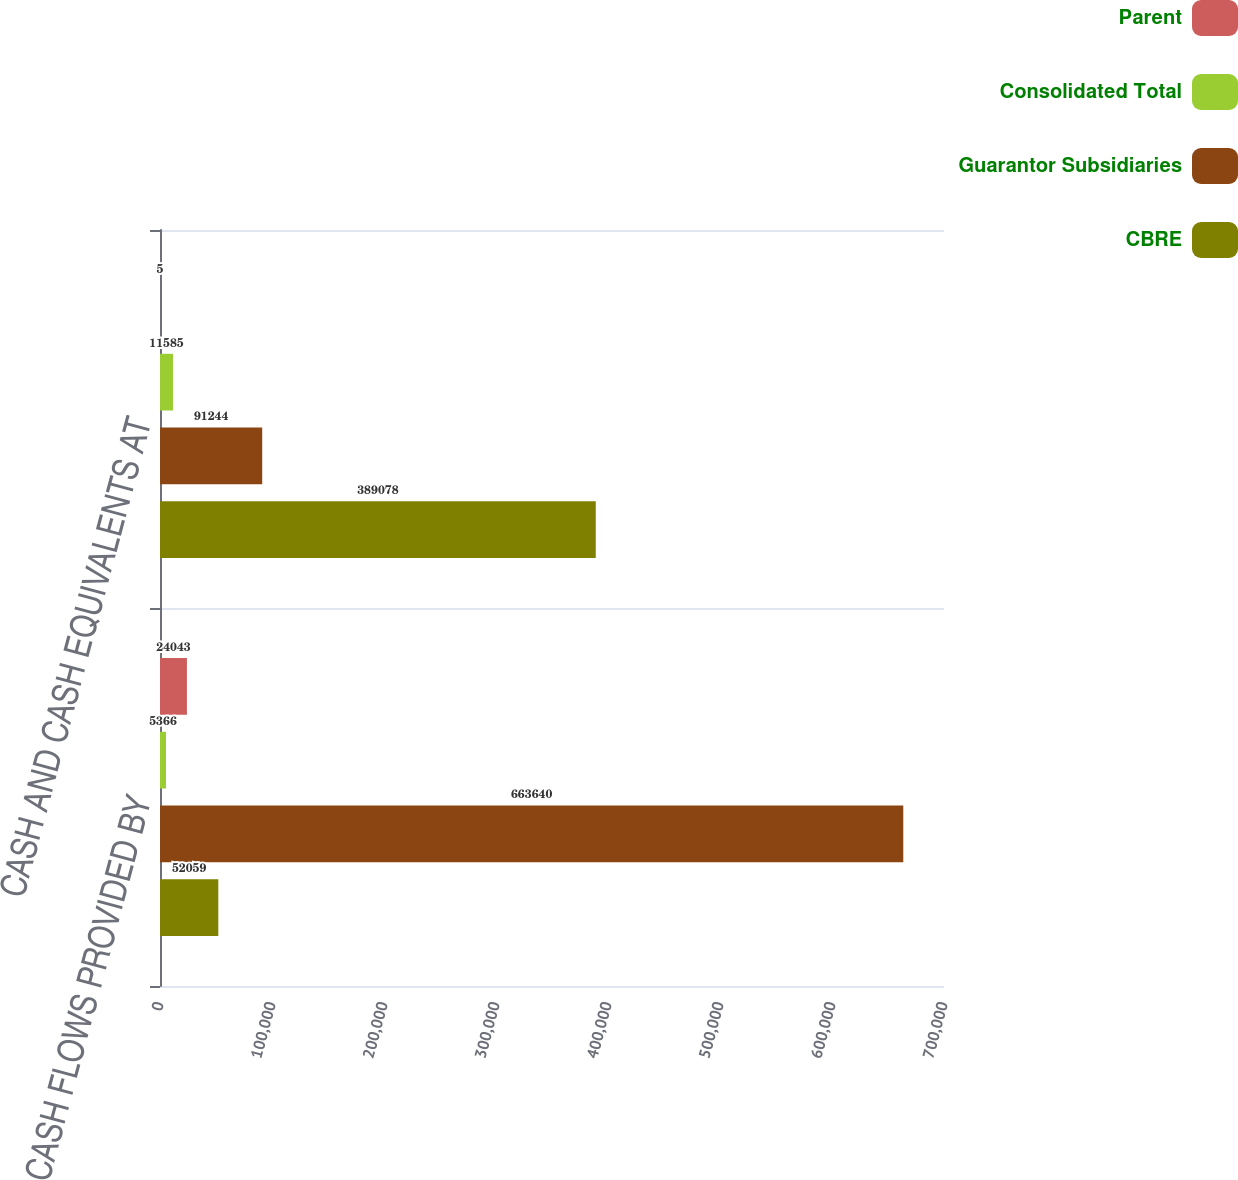Convert chart. <chart><loc_0><loc_0><loc_500><loc_500><stacked_bar_chart><ecel><fcel>CASH FLOWS PROVIDED BY<fcel>CASH AND CASH EQUIVALENTS AT<nl><fcel>Parent<fcel>24043<fcel>5<nl><fcel>Consolidated Total<fcel>5366<fcel>11585<nl><fcel>Guarantor Subsidiaries<fcel>663640<fcel>91244<nl><fcel>CBRE<fcel>52059<fcel>389078<nl></chart> 